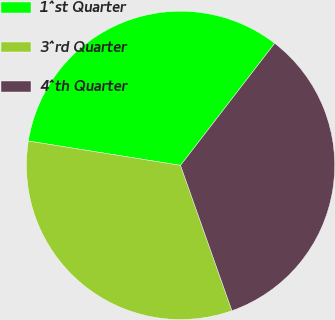Convert chart. <chart><loc_0><loc_0><loc_500><loc_500><pie_chart><fcel>1^st Quarter<fcel>3^rd Quarter<fcel>4^th Quarter<nl><fcel>32.93%<fcel>32.93%<fcel>34.13%<nl></chart> 